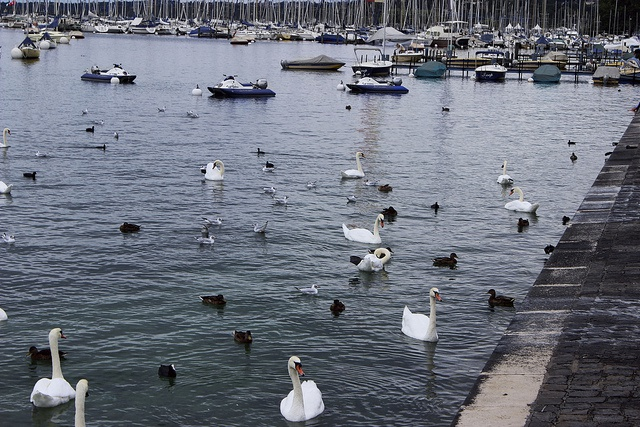Describe the objects in this image and their specific colors. I can see boat in gray, darkgray, and black tones, bird in gray, darkgray, and black tones, bird in gray, lightgray, and darkgray tones, bird in gray, lavender, darkgray, and black tones, and bird in gray, lavender, darkgray, and black tones in this image. 